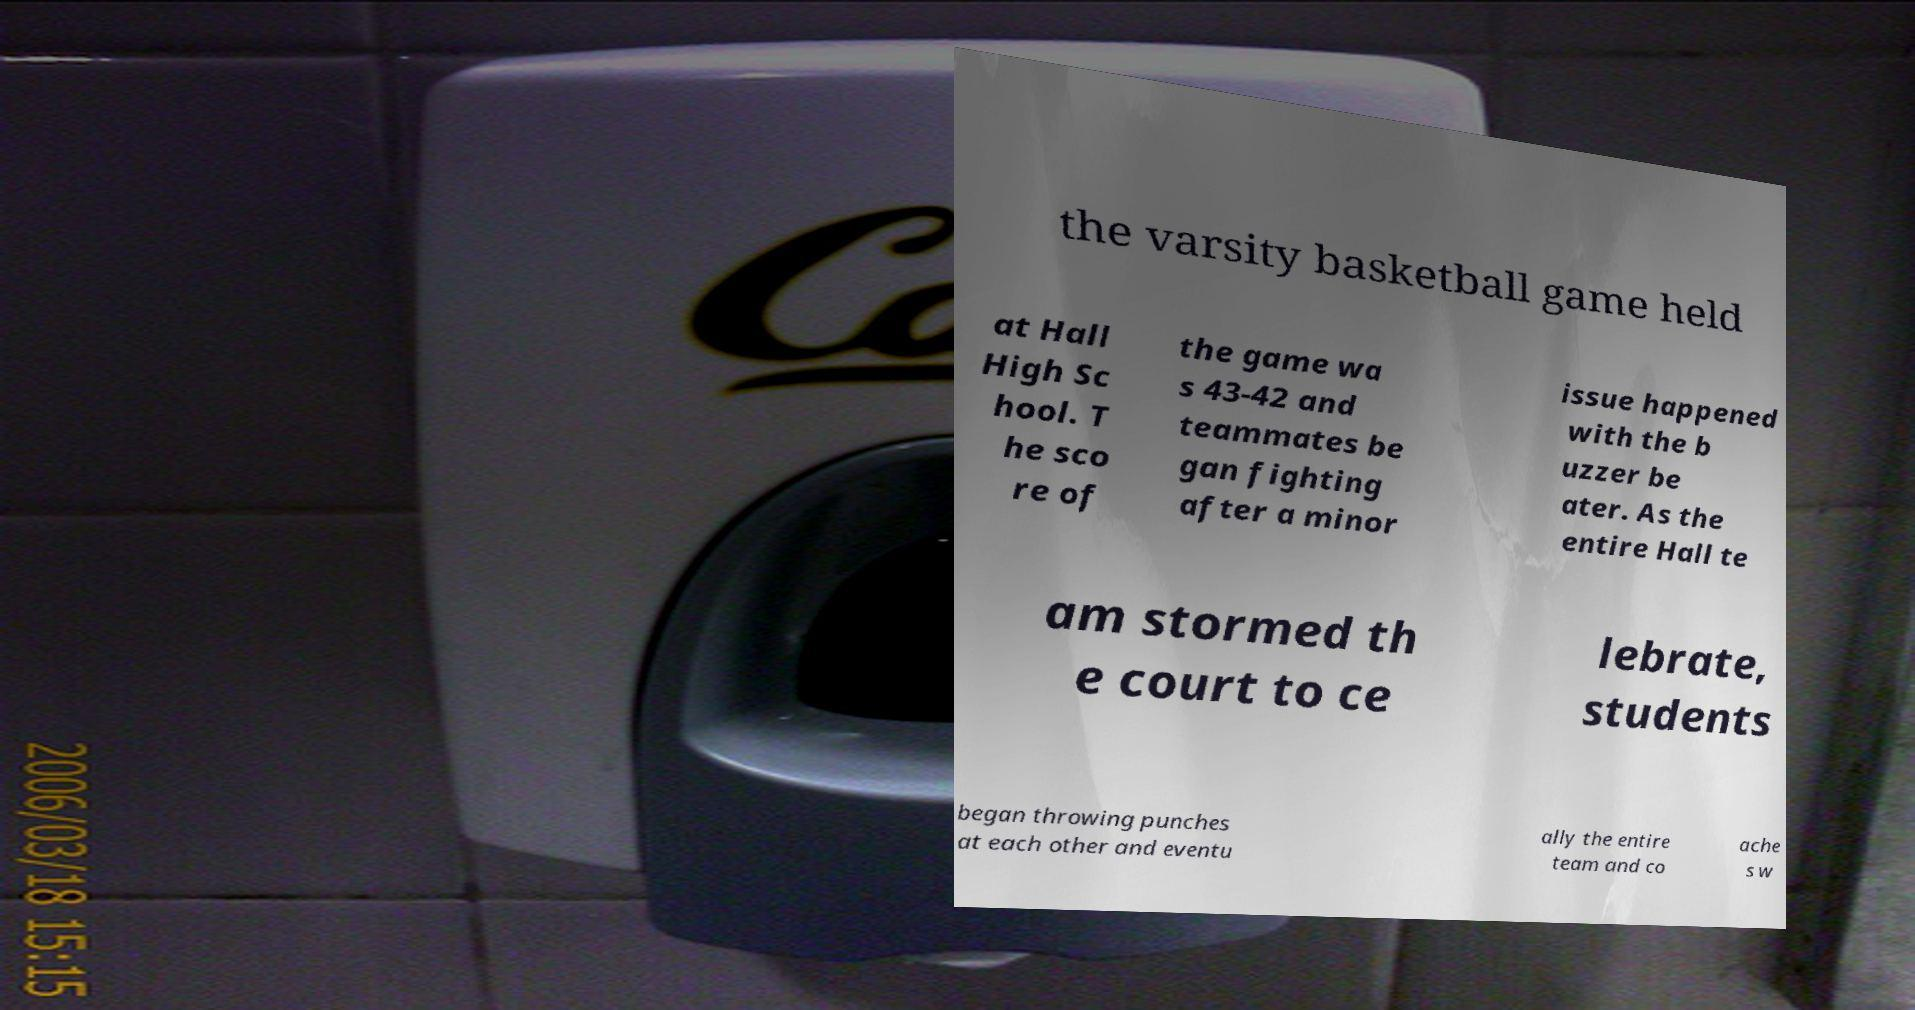I need the written content from this picture converted into text. Can you do that? the varsity basketball game held at Hall High Sc hool. T he sco re of the game wa s 43-42 and teammates be gan fighting after a minor issue happened with the b uzzer be ater. As the entire Hall te am stormed th e court to ce lebrate, students began throwing punches at each other and eventu ally the entire team and co ache s w 